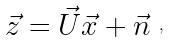<formula> <loc_0><loc_0><loc_500><loc_500>\begin{array} { l l l } \vec { z } = \vec { U } \vec { x } + \vec { n } \end{array} ,</formula> 